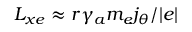<formula> <loc_0><loc_0><loc_500><loc_500>L _ { x e } \approx r \gamma _ { a } m _ { e } j _ { \theta } / | e |</formula> 